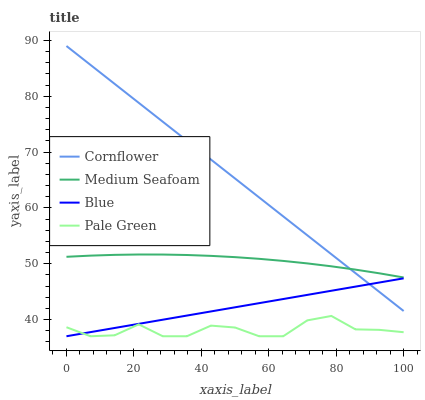Does Pale Green have the minimum area under the curve?
Answer yes or no. Yes. Does Cornflower have the maximum area under the curve?
Answer yes or no. Yes. Does Cornflower have the minimum area under the curve?
Answer yes or no. No. Does Pale Green have the maximum area under the curve?
Answer yes or no. No. Is Blue the smoothest?
Answer yes or no. Yes. Is Pale Green the roughest?
Answer yes or no. Yes. Is Cornflower the smoothest?
Answer yes or no. No. Is Cornflower the roughest?
Answer yes or no. No. Does Cornflower have the lowest value?
Answer yes or no. No. Does Cornflower have the highest value?
Answer yes or no. Yes. Does Pale Green have the highest value?
Answer yes or no. No. Is Blue less than Medium Seafoam?
Answer yes or no. Yes. Is Medium Seafoam greater than Pale Green?
Answer yes or no. Yes. Does Medium Seafoam intersect Cornflower?
Answer yes or no. Yes. Is Medium Seafoam less than Cornflower?
Answer yes or no. No. Is Medium Seafoam greater than Cornflower?
Answer yes or no. No. Does Blue intersect Medium Seafoam?
Answer yes or no. No. 